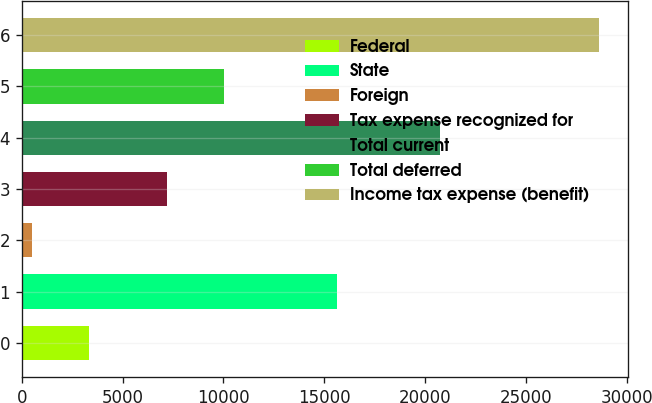Convert chart. <chart><loc_0><loc_0><loc_500><loc_500><bar_chart><fcel>Federal<fcel>State<fcel>Foreign<fcel>Tax expense recognized for<fcel>Total current<fcel>Total deferred<fcel>Income tax expense (benefit)<nl><fcel>3333.6<fcel>15651<fcel>523<fcel>7205<fcel>20734<fcel>10015.6<fcel>28629<nl></chart> 